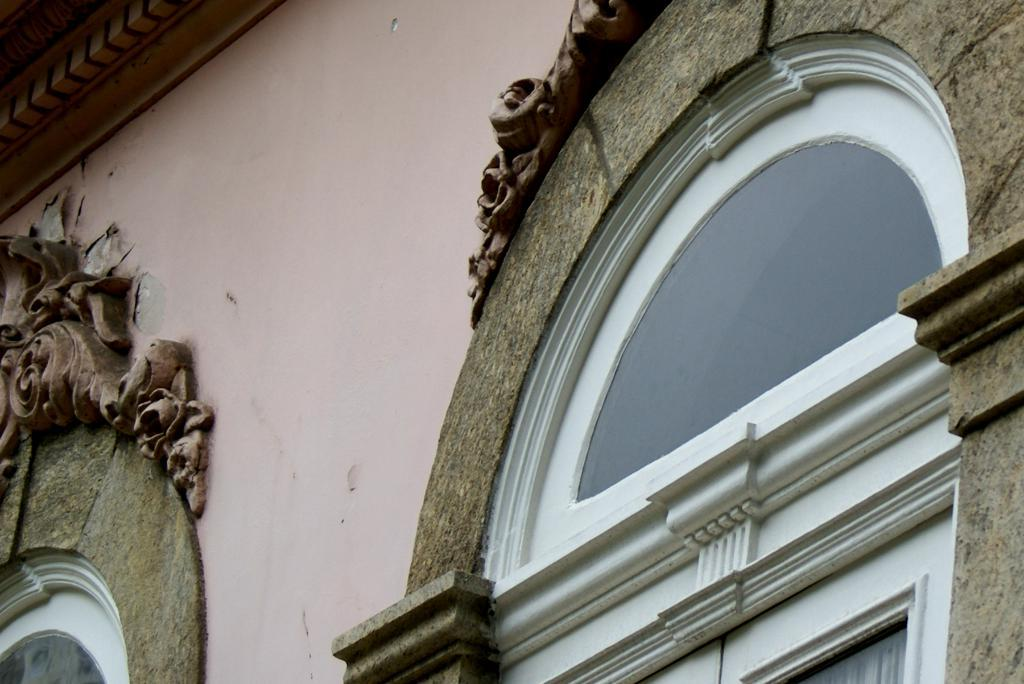What is located in the foreground of the image? There is a building in the foreground of the image. Can you describe any specific features of the building? There are two glass windows in the image. What type of show or protest is happening in front of the building in the image? There is no indication of a show or protest happening in front of the building in the image. Are there any giants visible in the image? There are no giants present in the image. 